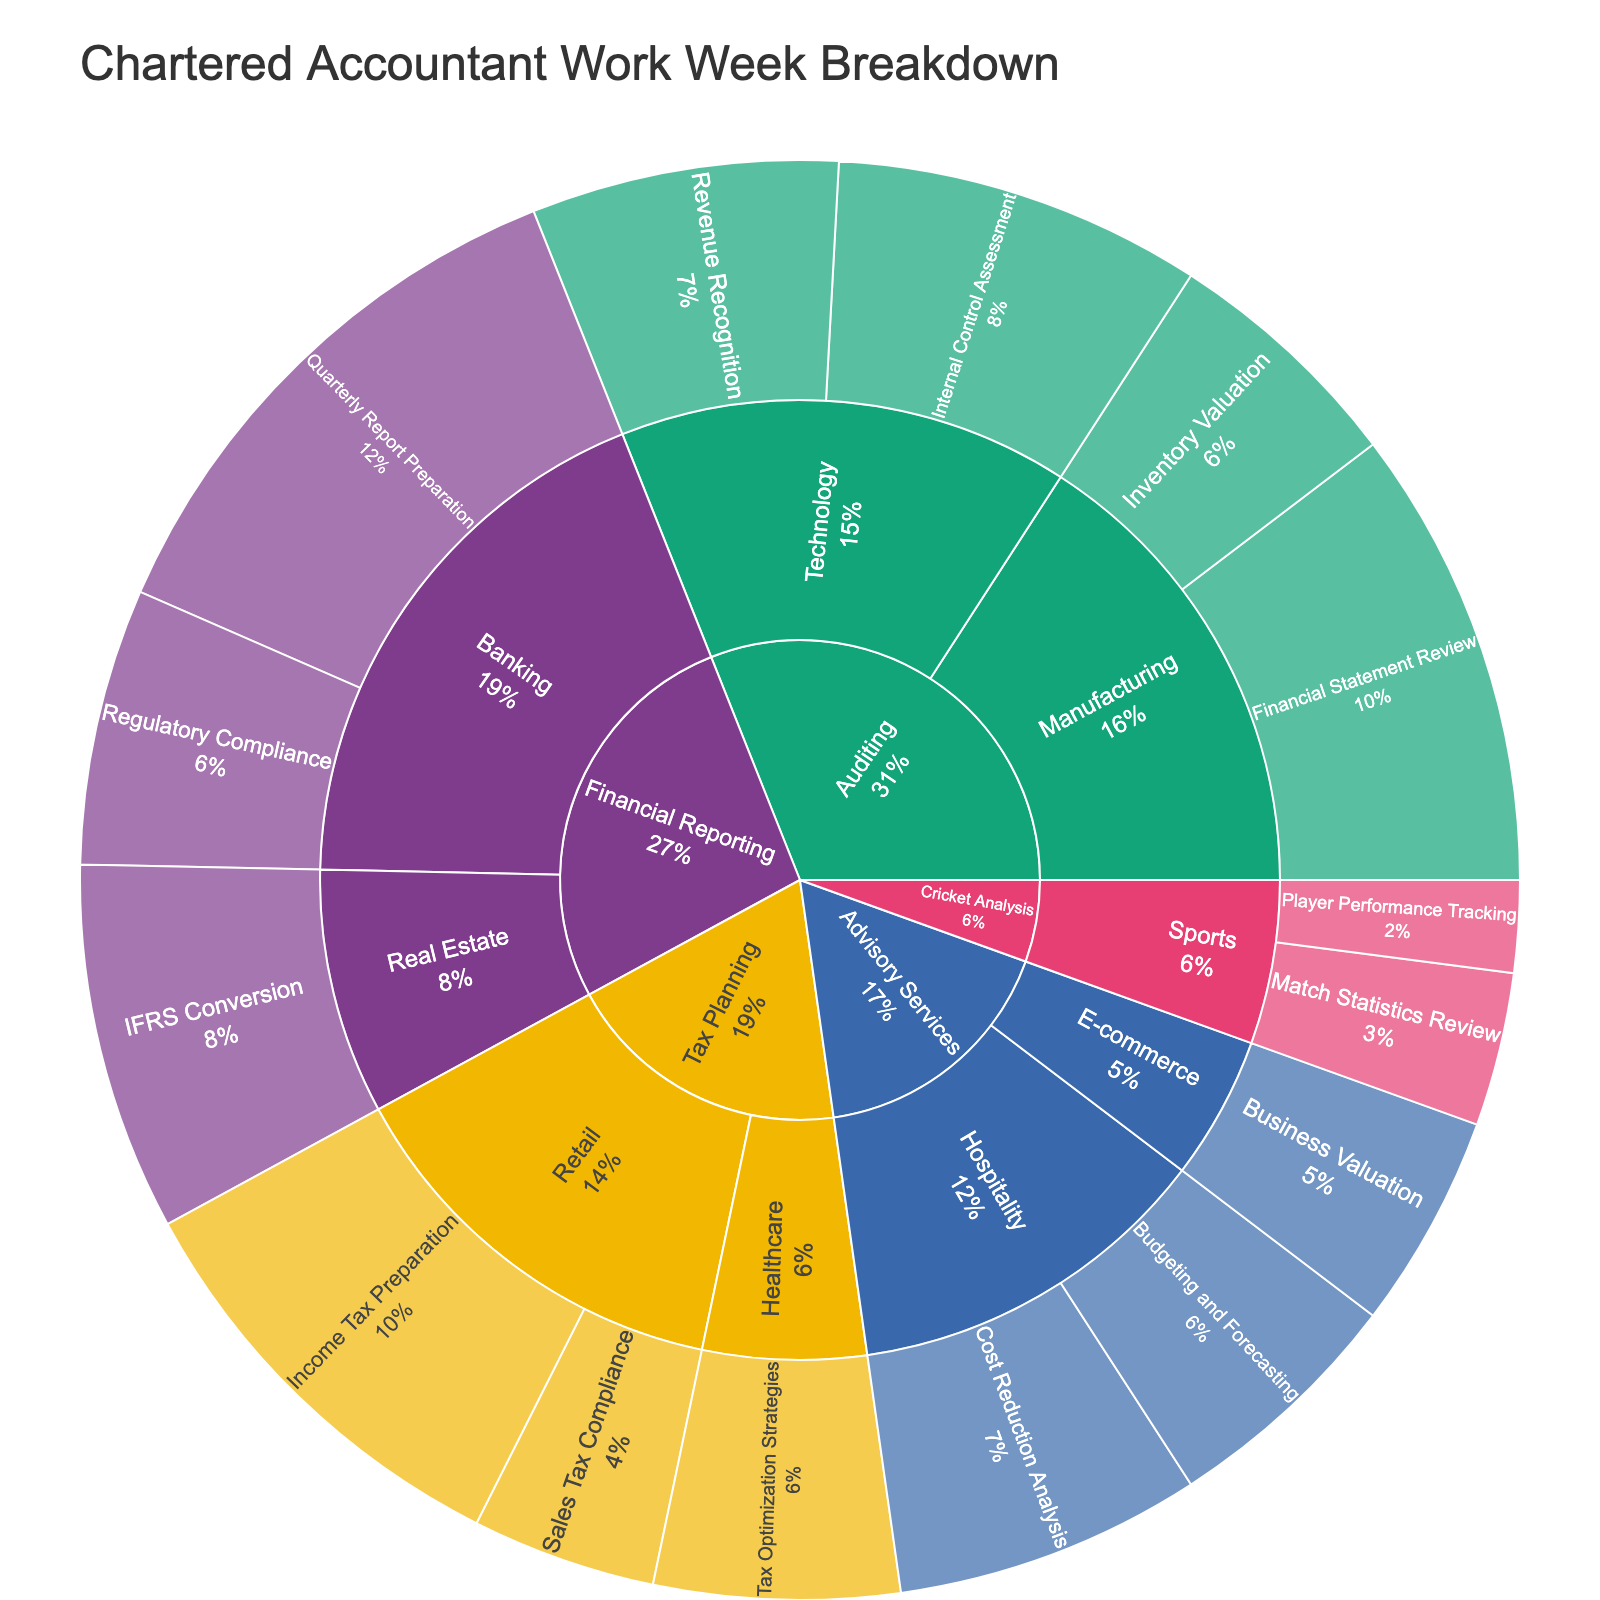How many hours are dedicated to Auditing in the Technology industry? By looking at the Auditing section and finding the Technology sub-sector, we can sum the hours of 'Internal Control Assessment' and 'Revenue Recognition' tasks which are 12 and 10 respectively, thus total hours are 12 + 10 = 22.
Answer: 22 Which Task Type has the highest total hours dedicated? By observing the sunburst plot, the Task Type with the largest segment is Financial Reporting with a total of 18 + 9 + 12 = 39 hours.
Answer: Financial Reporting What percentage of hours are spent on Tax Planning for the Retail industry? Identify the total hours spent on Tax Planning for the Retail industry (Income Tax Preparation: 14, Sales Tax Compliance: 6) which sums to 20 hours. Calculate its percentage of the total hours (sum of all listed hours which is 160). Thus, (20/160) * 100 = 12.5%.
Answer: 12.5% In the Hospitality industry, which specific task accounts for the higher number of hours and by how much? Compare the hours dedicated to 'Budgeting and Forecasting' (8 hours) and 'Cost Reduction Analysis' (10 hours) in the Hospitality industry. 'Cost Reduction Analysis' accounts for 10 - 8 = 2 more hours.
Answer: Cost Reduction Analysis, 2 Compare the hours spent on cricket-related tasks to those spent on auditing tasks in the Manufacturing industry. Sum the hours for cricket-related tasks (Match Statistics Review: 5, Player Performance Tracking: 3) which is 5 + 3 = 8. Sum the hours for auditing tasks in the Manufacturing industry (Financial Statement Review: 15, Inventory Valuation: 8) which is 15 + 8 = 23. The difference is 23 - 8 = 15 hours more on auditing.
Answer: 15 more on auditing What is the average number of hours spent on each specific task for Financial Reporting? List the hours spent on each specific task under Financial Reporting (Quarterly Report Preparation: 18, Regulatory Compliance: 9, IFRS Conversion: 12), sum them to get a total of 18 + 9 + 12 = 39 hours, then divide by the number of specific tasks (3). The average is 39/3 = 13.
Answer: 13 Which Client Industry has the least number of hours dedicated to it? The sunburst segment for E-commerce under Advisory Services shows the smallest segment with 'Business Valuation' task which is 7 hours.
Answer: E-commerce What percentage of the total hours are spent on Advisory Services in the Hospitality industry? The total hours dedicated to Advisory Services in Hospitality are from 'Cost Reduction Analysis' (10) and 'Budgeting and Forecasting' (8), so total is 10 + 8 = 18. The overall total hours are 160. Thus, (18 / 160) * 100 = 11.25%.
Answer: 11.25% How many more hours are spent on Financial Reporting in Banking compared to Real Estate? Compare total hours for Financial Reporting in Banking (Quarterly Report Preparation: 18, Regulatory Compliance: 9) which sums to 27, with Real Estate's total (IFRS Conversion: 12), and subtract them: 27 - 12 = 15 hours.
Answer: 15 